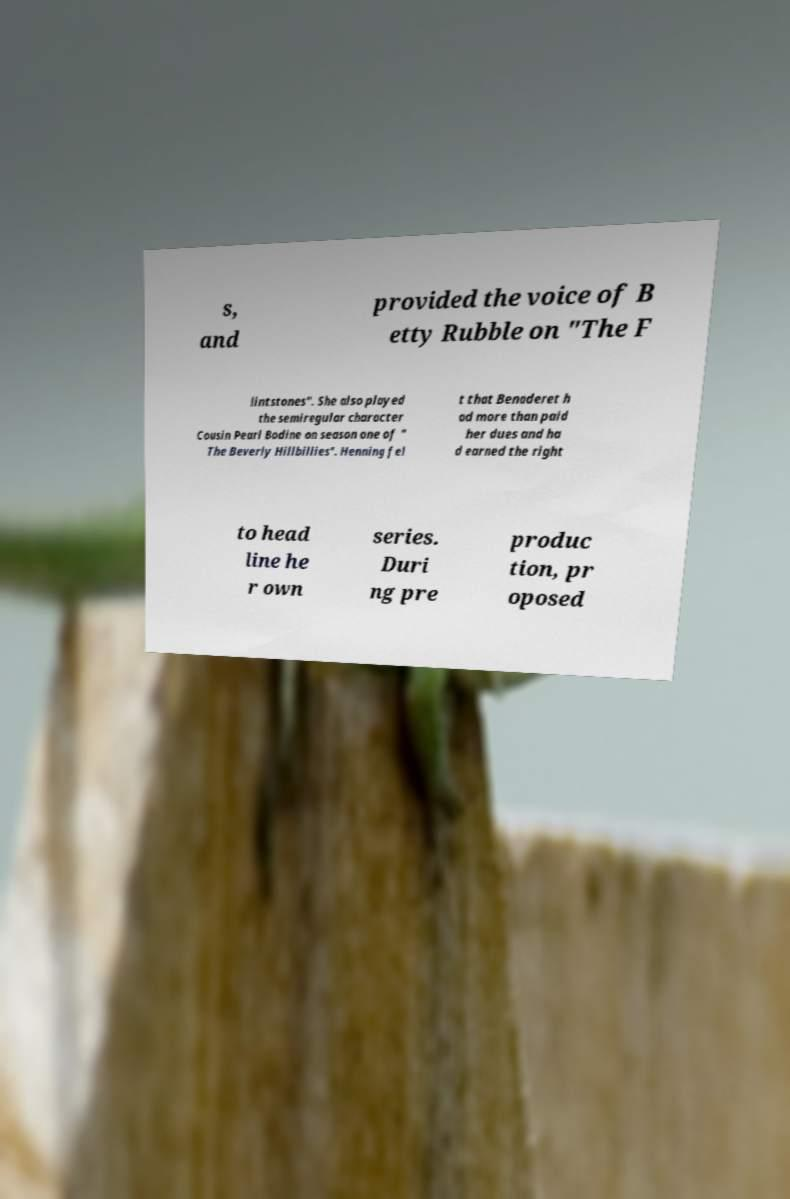Please read and relay the text visible in this image. What does it say? s, and provided the voice of B etty Rubble on "The F lintstones". She also played the semiregular character Cousin Pearl Bodine on season one of " The Beverly Hillbillies". Henning fel t that Benaderet h ad more than paid her dues and ha d earned the right to head line he r own series. Duri ng pre produc tion, pr oposed 